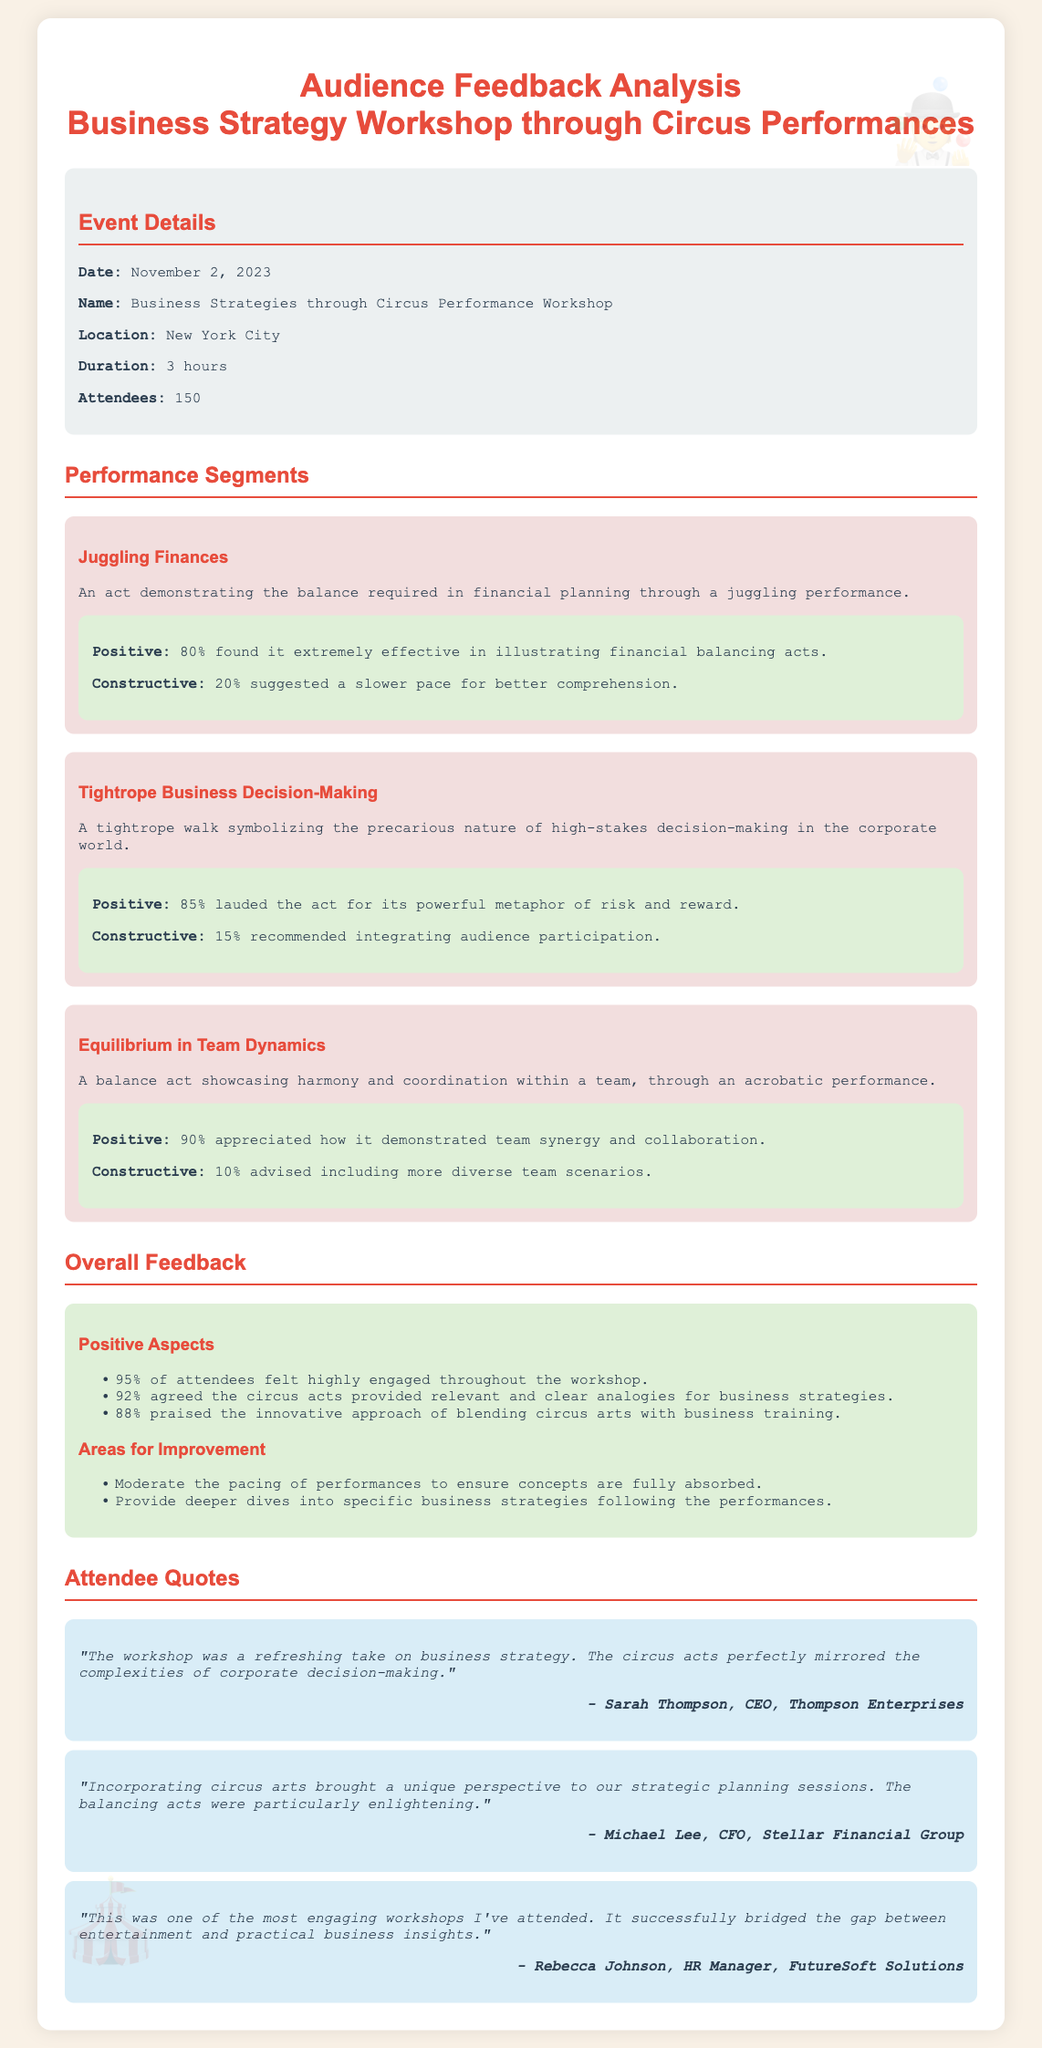what is the date of the workshop? The date of the workshop is mentioned in the event details section of the document.
Answer: November 2, 2023 how many attendees were at the workshop? The total number of attendees is listed in the event details section.
Answer: 150 what performance demonstrated financial planning? The performance segment that illustrates financial planning is detailed in the performance segments section.
Answer: Juggling Finances what percentage of attendees felt highly engaged? This percentage is provided in the overall feedback section for positive aspects.
Answer: 95% which act was praised for showcasing team synergy? The feedback about the act demonstrating team synergy is found in the performance segments section.
Answer: Equilibrium in Team Dynamics what was a suggested area for improvement? Suggestions for improvement can be found in the areas for improvement section of overall feedback.
Answer: Moderate the pacing of performances who is the CEO that provided a quote? The name of the CEO who provided feedback is mentioned in the attendee quotes section.
Answer: Sarah Thompson what metaphor did the tightrope act symbolize? The symbolism of the tightrope act is explained in the description of that specific performance.
Answer: risk and reward how many found the juggling act effective? The effectiveness of the juggling act is presented in the feedback for that performance.
Answer: 80% 